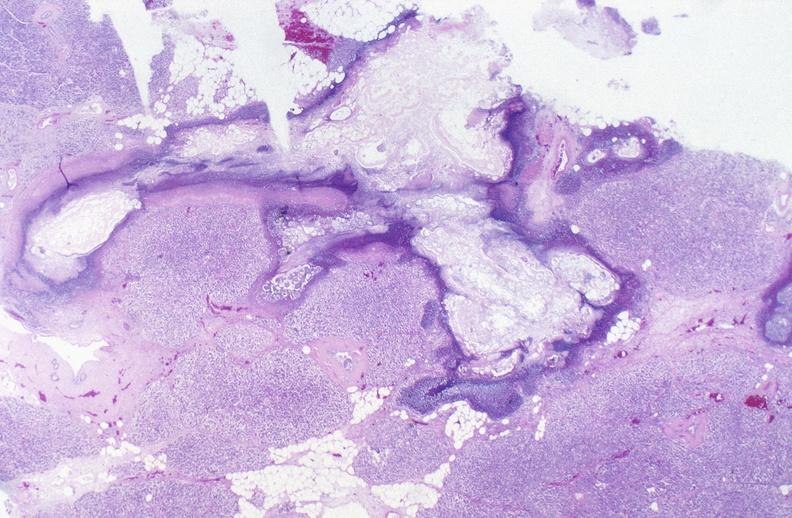does this image show pancreatic fat necrosis?
Answer the question using a single word or phrase. Yes 